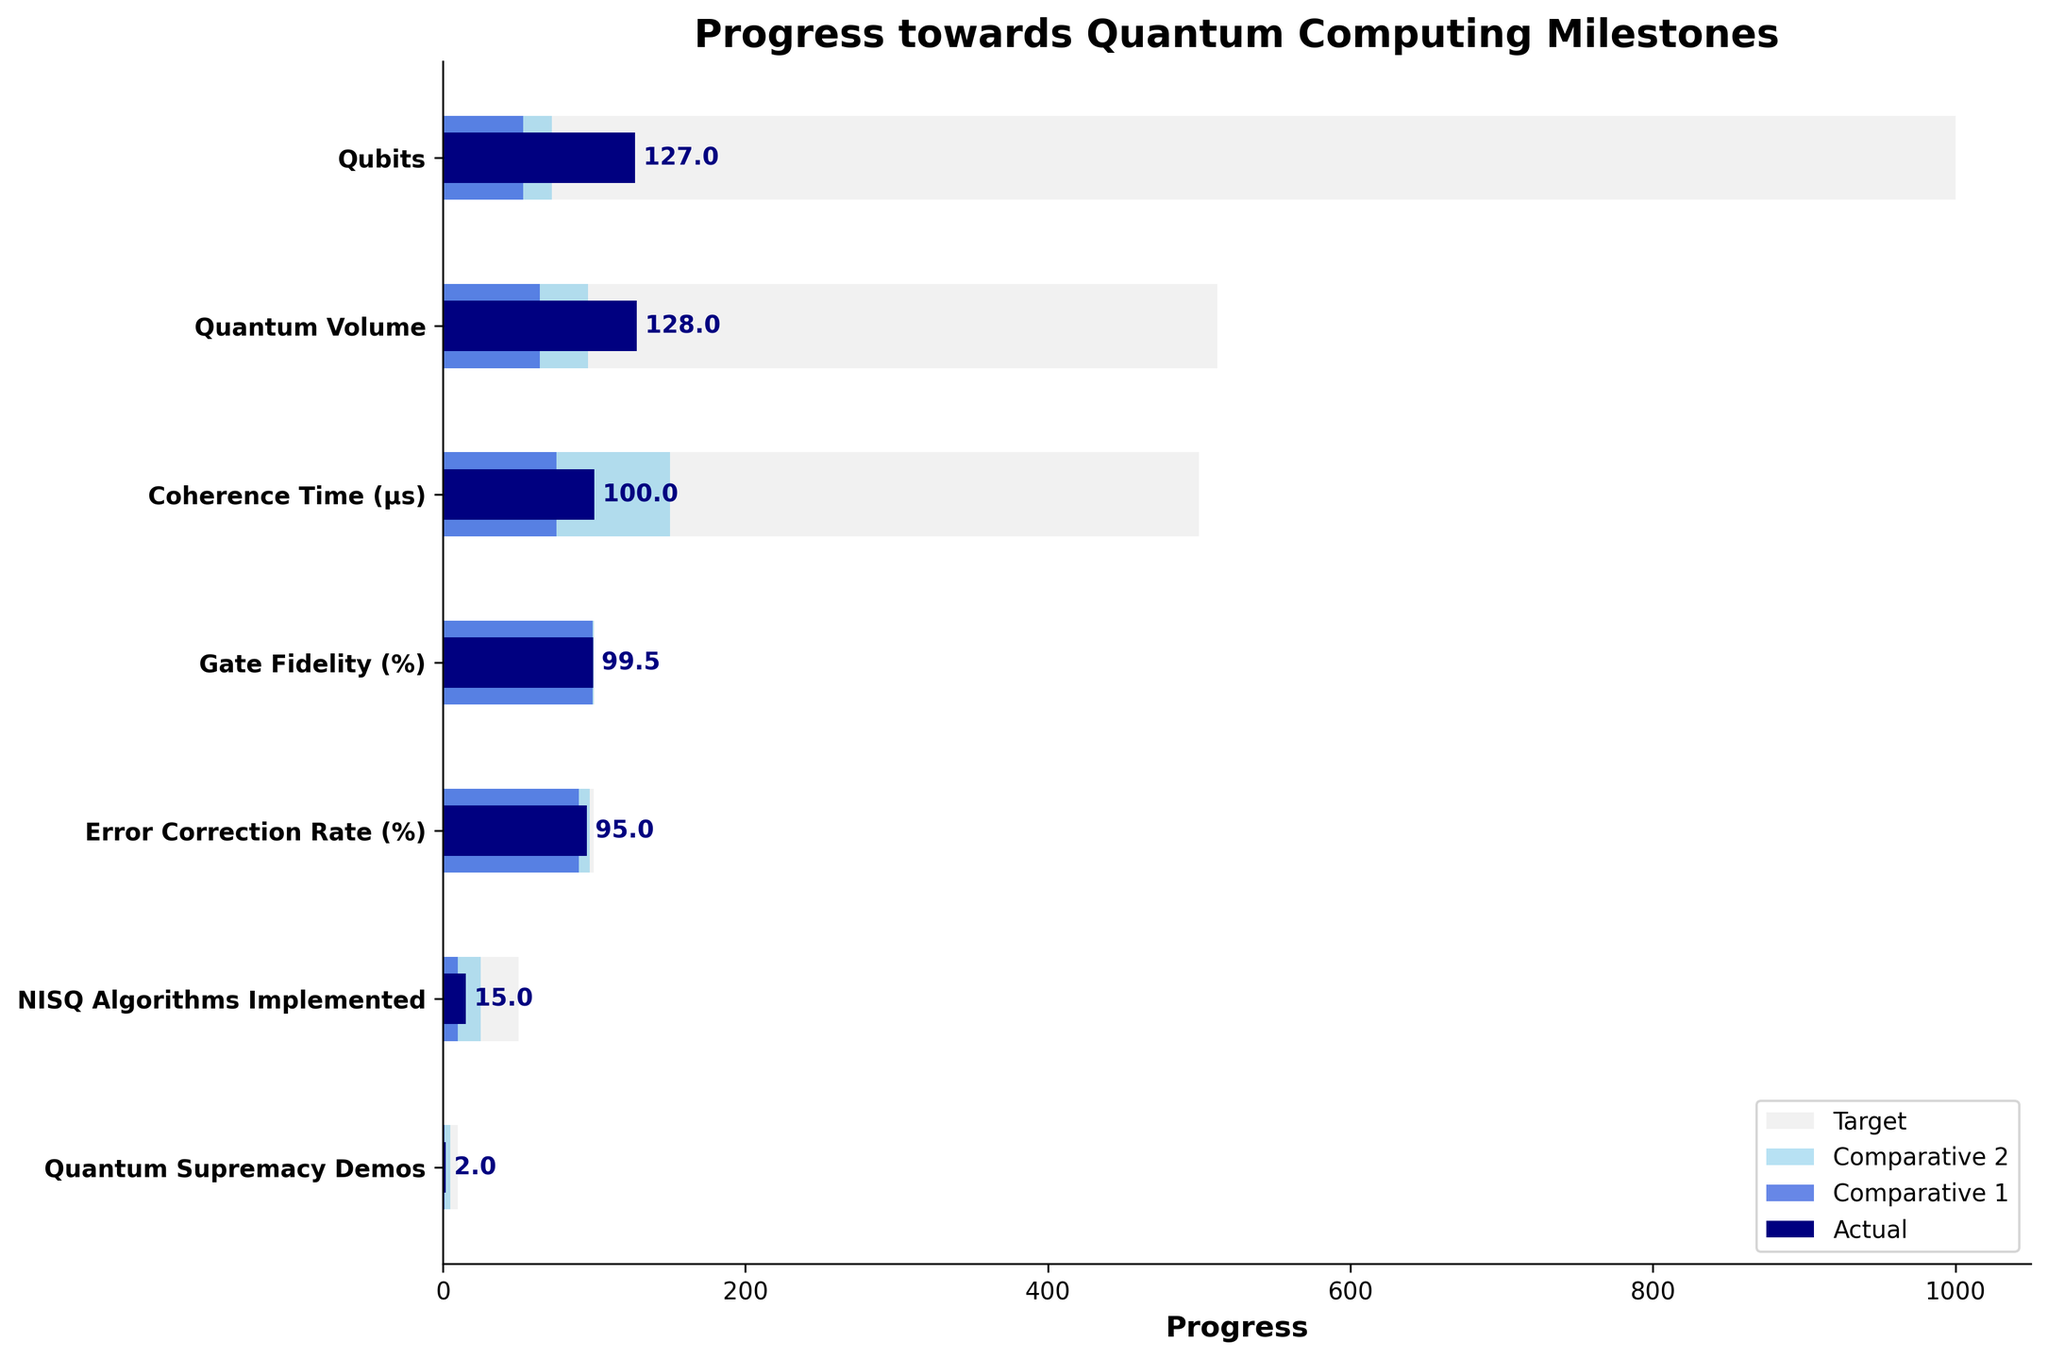What is the title of the figure? The title of the figure is displayed at the top and reads 'Progress towards Quantum Computing Milestones'.
Answer: Progress towards Quantum Computing Milestones How many categories are displayed in the figure? By counting the labeled categories on the y-axis, we can see there are 7 categories listed.
Answer: 7 In which category is there the largest gap between the actual value and the target value? To determine the largest gap, calculate the difference between the actual value and the target value for each category, and identify the category with the highest difference. The coherence time (μs) has a target of 500 and an actual value of 100, resulting in a gap of 400 units, the highest among all categories.
Answer: Coherence Time (μs) How does the progress in 'Quantum Volume' compare to 'Error Correction Rate (%)'? Comparing the actual values, targets, and comparative benchmarks for both, Quantum Volume has an actual value of 128 against a target of 512, showing significant progress but not meeting the target. Error Correction Rate has an actual value of 95% against a target of 99.9%. Despite being close to its target, it is slightly below other comparatives unlike Quantum Volume which has surpassed one comparative (64).
Answer: Quantum Volume is closer to its comparatives but further from its target compared to the Error Correction Rate What is the average actual value across all categories? To find the average, sum the actual values of all categories and divide by the number of categories: (127 + 128 + 100 + 99.5 + 95 + 15 + 2) / 7 = 81.36 (rounded).
Answer: 81.36 Which category has the actual value closest to its target? Identify the category with the smallest difference between the actual value and the target. Gate Fidelity has an actual value of 99.5% and a target of 99.99%, with a difference of 0.49%, the smallest among all categories.
Answer: Gate Fidelity (%) What colors represent the target, Comparative 1, Comparative 2, and actual values? The colors can be observed from the bars in the figure: light grey for the target, royal blue for Comparative 1, sky blue for Comparative 2, and navy for the actual values.
Answer: Light grey, royal blue, sky blue, navy 